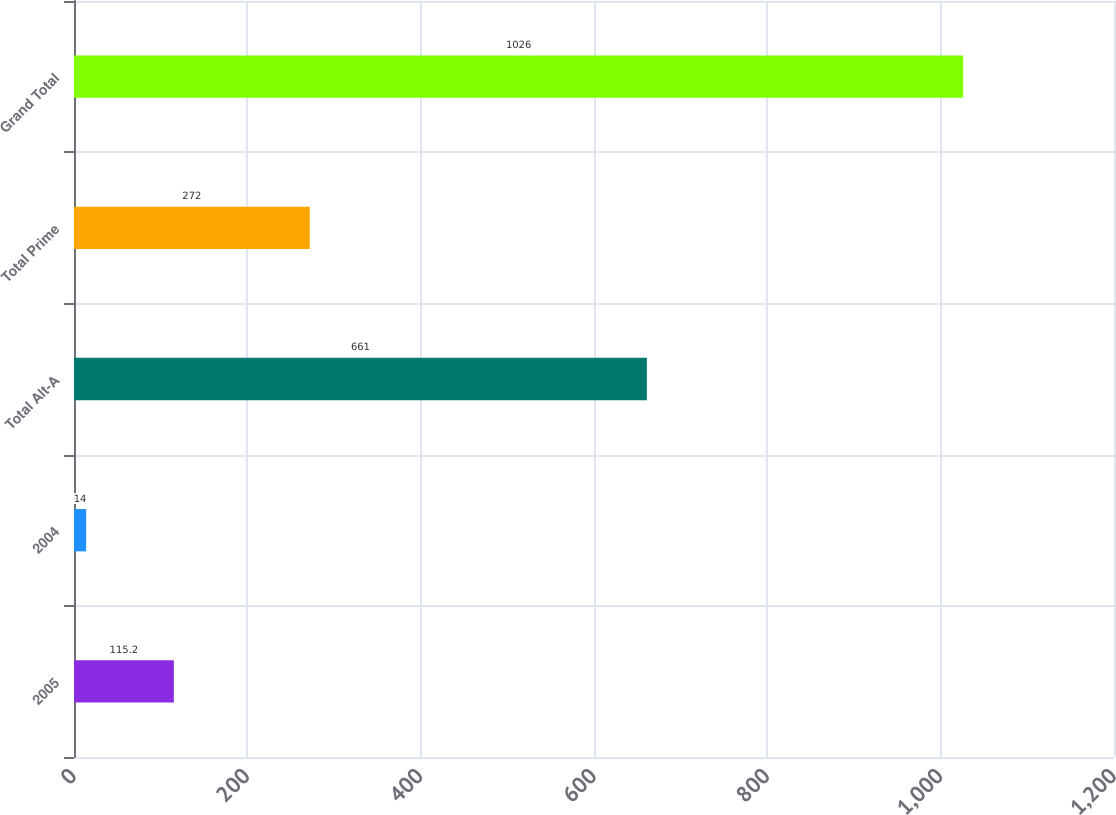Convert chart to OTSL. <chart><loc_0><loc_0><loc_500><loc_500><bar_chart><fcel>2005<fcel>2004<fcel>Total Alt-A<fcel>Total Prime<fcel>Grand Total<nl><fcel>115.2<fcel>14<fcel>661<fcel>272<fcel>1026<nl></chart> 